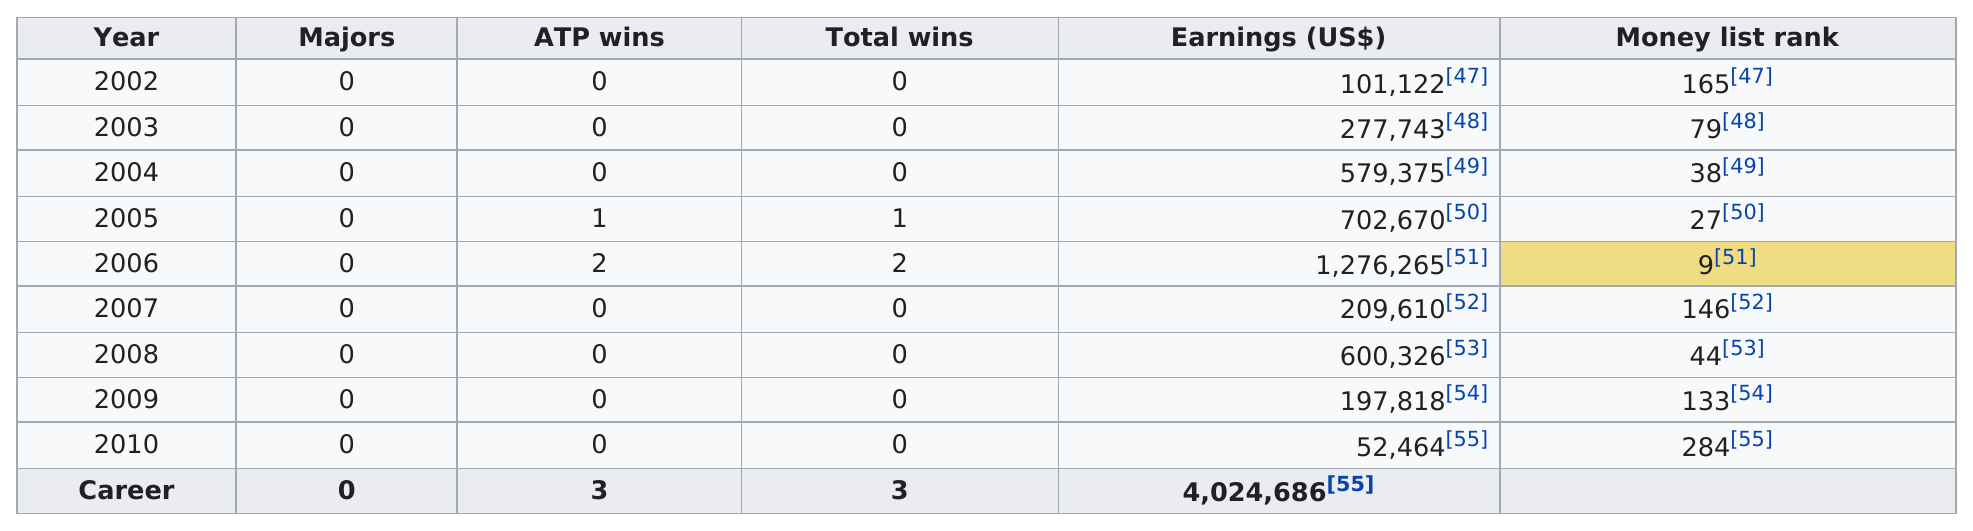Specify some key components in this picture. Mario Ancic did not win an ATP tournament in the year 2006. For two consecutive years, ATP wins were recorded in 2005 and 2006. In 2010, the least amount of earnings was won. The higher listing of monetary earnings was recorded in 2003. Mario Ančić dropped 137 spots on the ATP Tour money list from 2006 to 2007. 